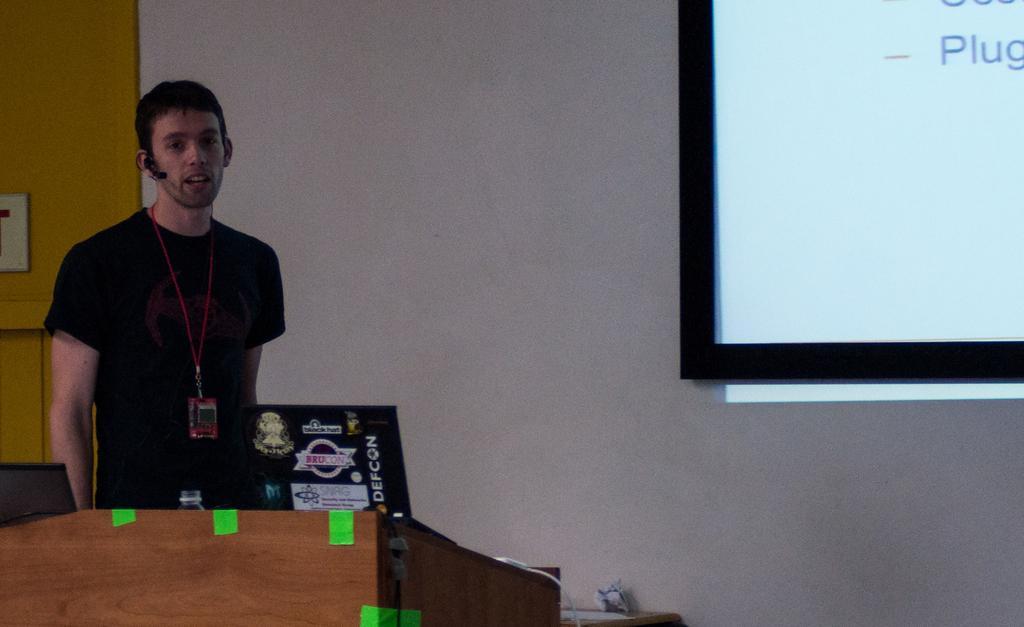In one or two sentences, can you explain what this image depicts? In this image there is a person on the left side visible in front of a podium on the left side, behind him may be there is the wall, on which there is a screen on the right side, there is a cable cord visible at the bottom on the top of podium. 